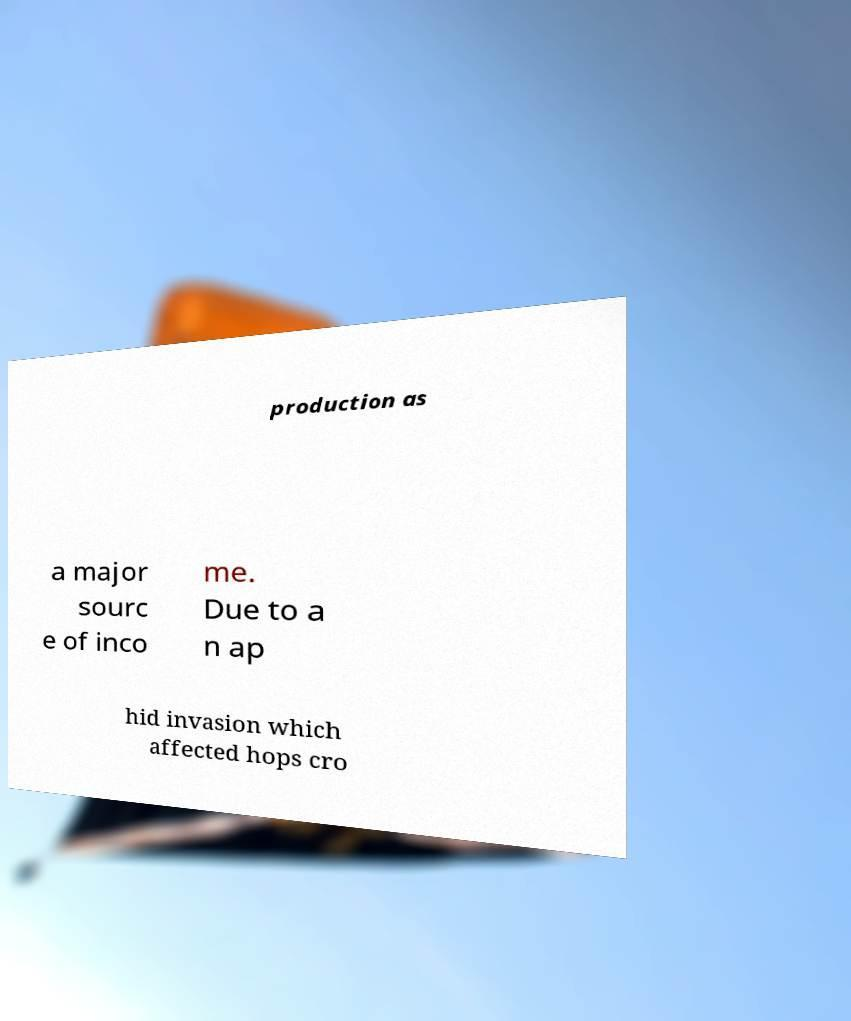I need the written content from this picture converted into text. Can you do that? production as a major sourc e of inco me. Due to a n ap hid invasion which affected hops cro 